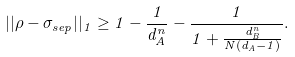Convert formula to latex. <formula><loc_0><loc_0><loc_500><loc_500>| | \rho - \sigma _ { s e p } | | _ { 1 } \geq 1 - \frac { 1 } { d _ { A } ^ { n } } - \frac { 1 } { 1 + \frac { d _ { B } ^ { n } } { N ( d _ { A } - 1 ) } } .</formula> 